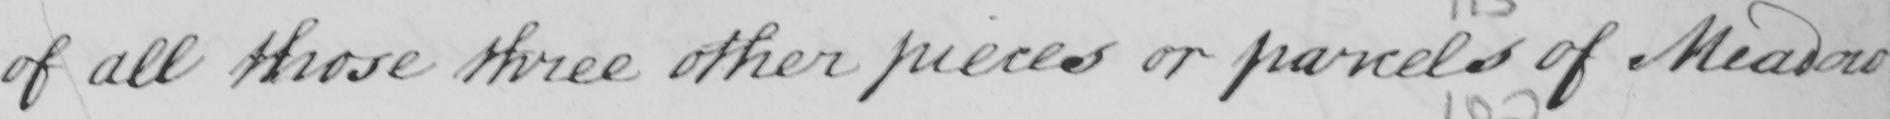Can you read and transcribe this handwriting? of all those three other pieces or parcels of Meadow 